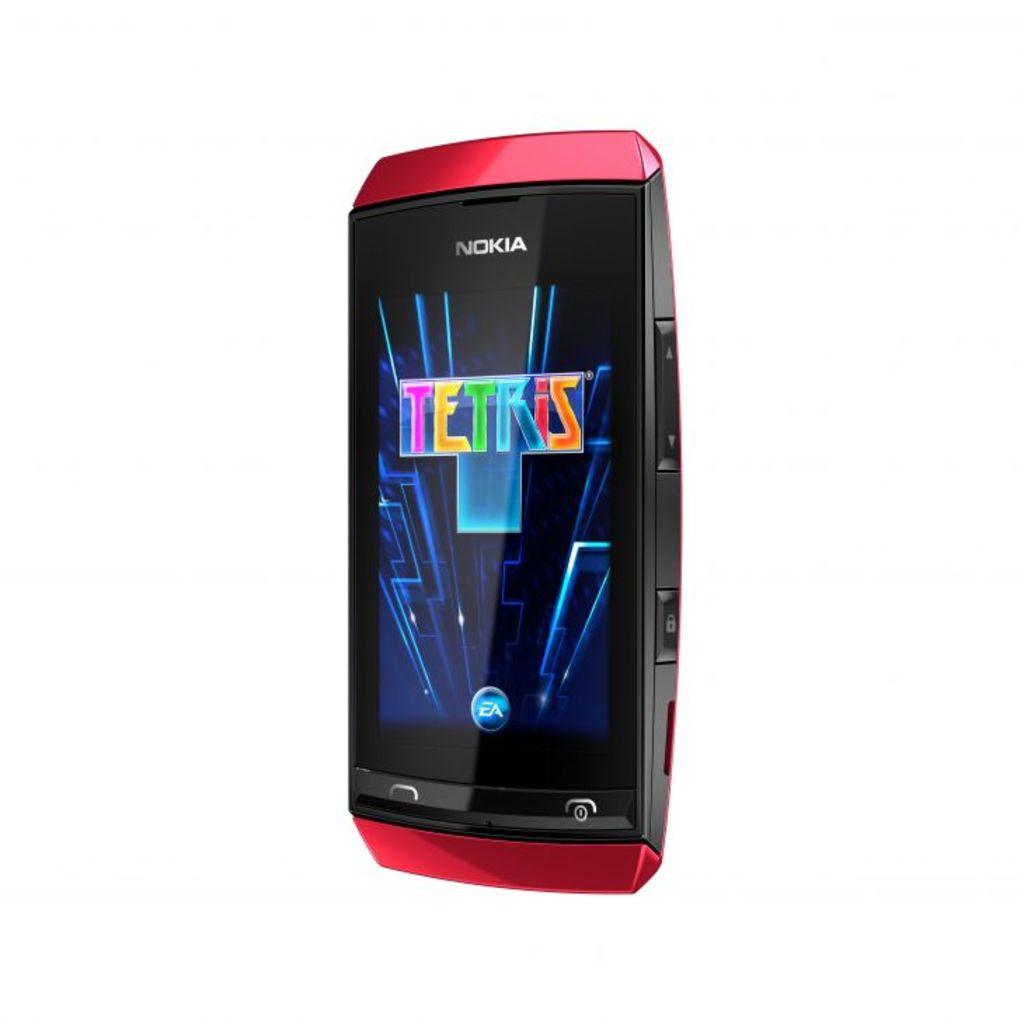What brand of phone is this?
Keep it short and to the point. Nokia. What game is on the phone?
Your response must be concise. Tetris. 